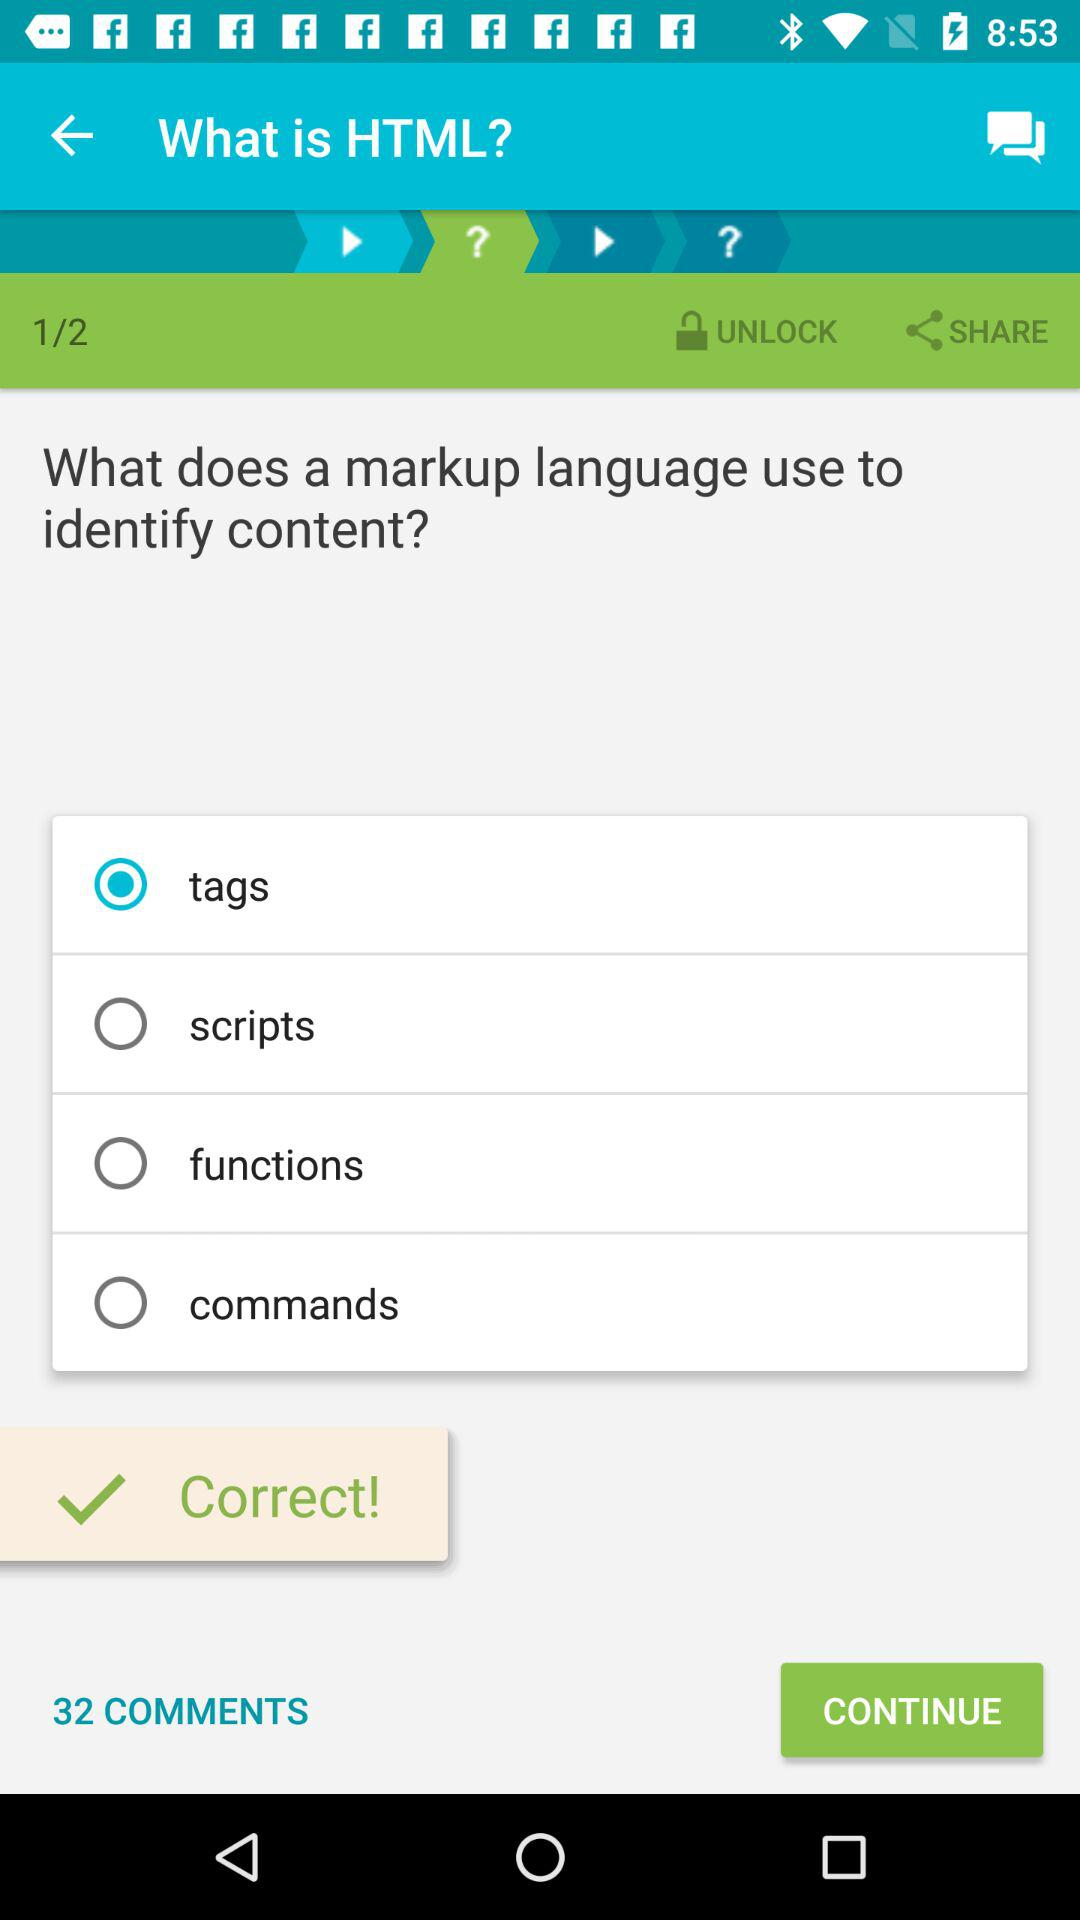How many comments are there? There are 32 comments. 